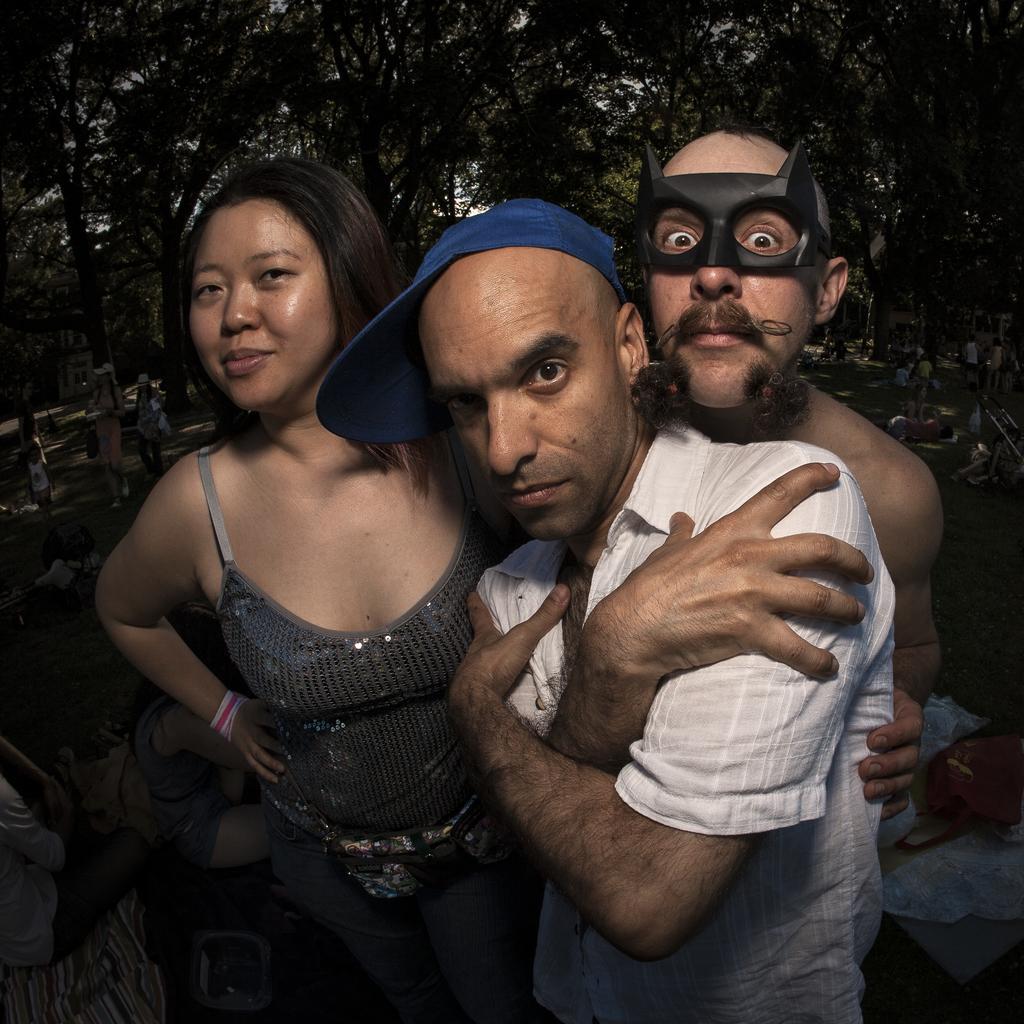How would you summarize this image in a sentence or two? This picture describes about group of people, in the middle of the image we can see a man, he wore a cap, behind him we can see another man, he wore a mask, in the background we can find few trees. 